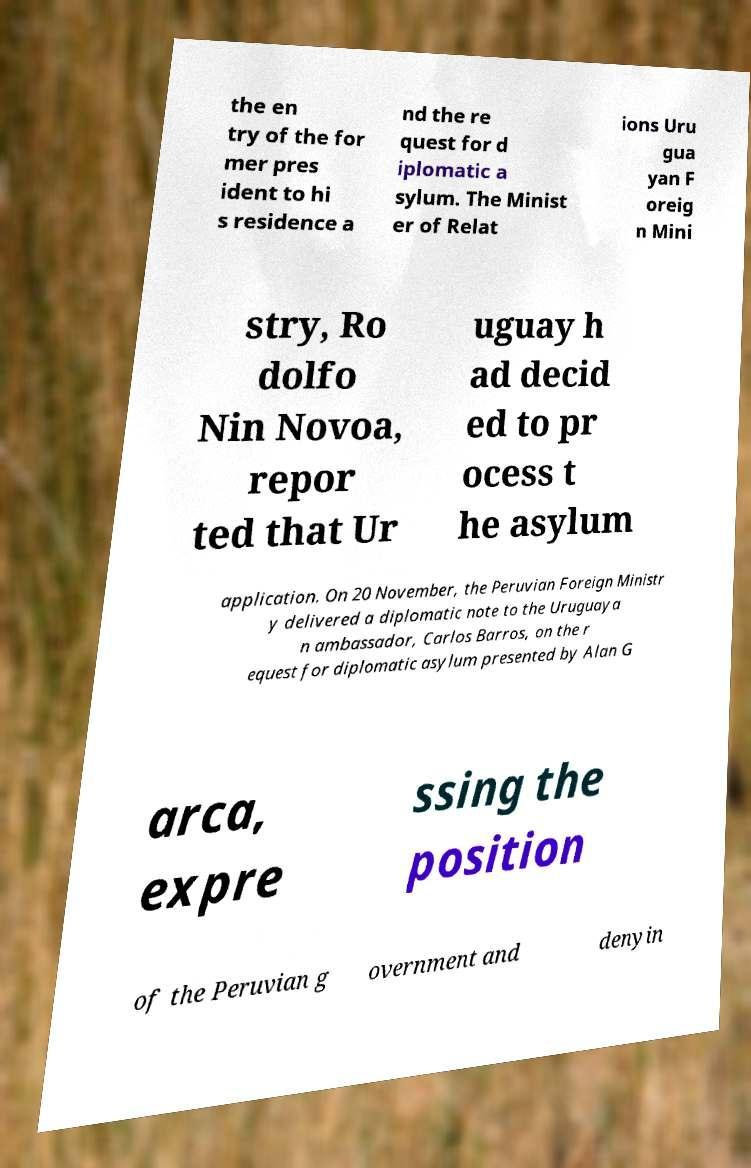I need the written content from this picture converted into text. Can you do that? the en try of the for mer pres ident to hi s residence a nd the re quest for d iplomatic a sylum. The Minist er of Relat ions Uru gua yan F oreig n Mini stry, Ro dolfo Nin Novoa, repor ted that Ur uguay h ad decid ed to pr ocess t he asylum application. On 20 November, the Peruvian Foreign Ministr y delivered a diplomatic note to the Uruguaya n ambassador, Carlos Barros, on the r equest for diplomatic asylum presented by Alan G arca, expre ssing the position of the Peruvian g overnment and denyin 